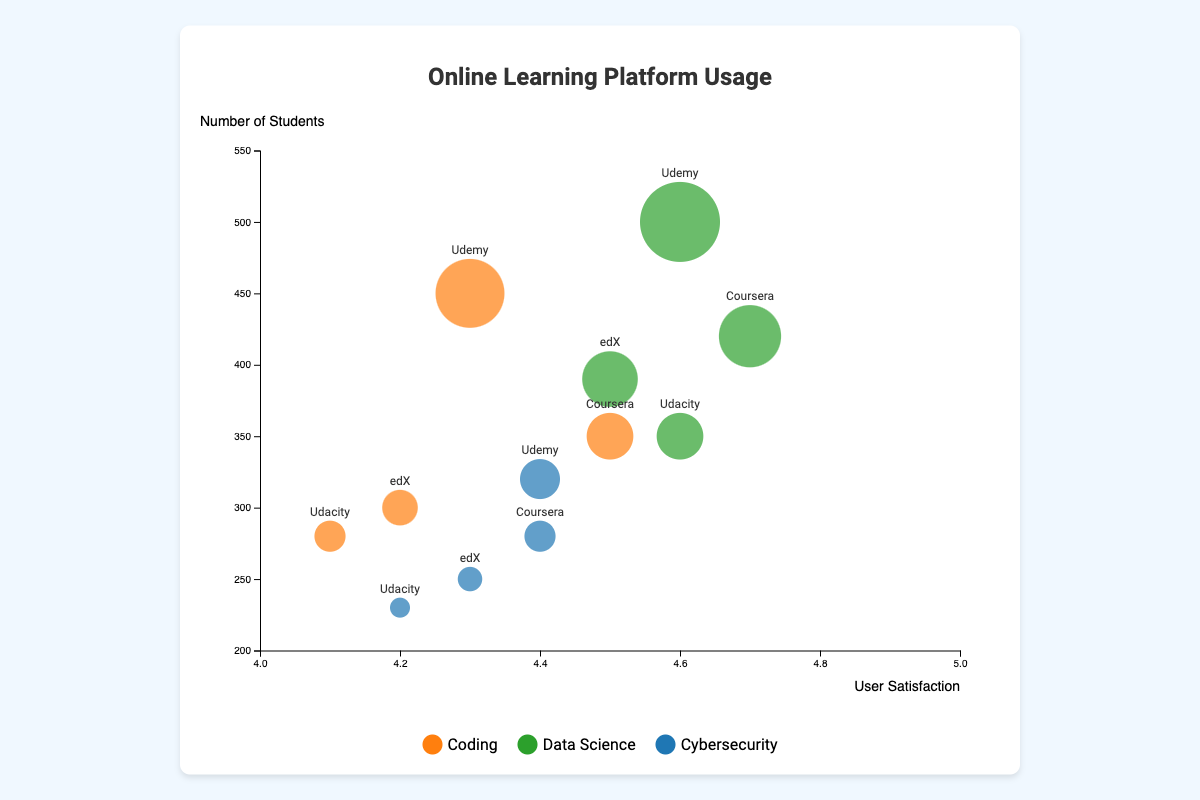Which platform offers coding courses to the highest number of students? By examining the size of the bubbles corresponding to each platform’s coding courses, the bubble for Udemy is the largest, indicating it offers coding courses to the highest number of students (450).
Answer: Udemy Which course type on Coursera has the highest user satisfaction rating? Looking at the x-axis position, the bubble representing Coursera’s data science course is furthest to the right, showing it has the highest user satisfaction rating of 4.7.
Answer: Data Science How many more students are enrolled in coding courses on Udemy compared to Udacity? The bubbles representing Udemy and Udacity coding courses show 450 and 280 students, respectively. The difference is calculated as 450 - 280 = 170.
Answer: 170 Which platform’s cybersecurity courses have the lowest user satisfaction rating? Checking the x-axis positions of bubbles for cybersecurity courses, Udacity's bubble is farthest to the left, with a user satisfaction rating of 4.2.
Answer: Udacity What is the average user satisfaction rating for coding courses across all platforms? The ratings are 4.5 (Coursera), 4.2 (edX), 4.1 (Udacity), and 4.3 (Udemy). The average is (4.5 + 4.2 + 4.1 + 4.3) / 4 = 4.28.
Answer: 4.28 Which platform has the highest user satisfaction rating for all course types combined? Calculating the x-axis averages: 
    - Coursera: (4.5 + 4.7 + 4.4) / 3 = 4.53
    - edX: (4.2 + 4.5 + 4.3) / 3 = 4.33
    - Udacity: (4.1 + 4.6 + 4.2) / 3 = 4.3
    - Udemy: (4.3 + 4.6 + 4.4) / 3 = 4.43 
The highest is Coursera with an average of 4.53.
Answer: Coursera Is the user satisfaction rating for cybersecurity courses on Udemy greater than coding courses on edX? Comparing the x-axis positions, Udemy's cybersecurity course rating is 4.4, while edX's coding course rating is 4.2. Since 4.4 > 4.2, the answer is yes.
Answer: Yes What is the most popular course type among students on all platforms? Sum the numbers of students per course type: 
    - Coding: 350 (Coursera) + 300 (edX) + 280 (Udacity) + 450 (Udemy) = 1380
    - Data Science: 420 (Coursera) + 390 (edX) + 350 (Udacity) + 500 (Udemy) = 1660
    - Cybersecurity: 280 (Coursera) + 250 (edX) + 230 (Udacity) + 320 (Udemy) = 1080 
Data Science has the highest total of 1660 students.
Answer: Data Science 